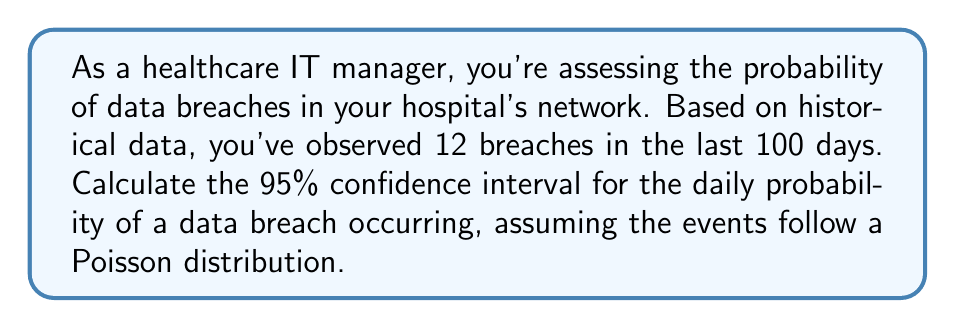Show me your answer to this math problem. Let's approach this step-by-step:

1) First, we need to calculate the point estimate for the daily probability of a data breach:
   $\hat{p} = \frac{\text{Number of breaches}}{\text{Number of days}} = \frac{12}{100} = 0.12$

2) For a Poisson distribution, the variance is equal to the mean. In this case, the mean is 12 breaches in 100 days.

3) The standard error (SE) for the Poisson distribution is given by:
   $SE = \sqrt{\frac{\lambda}{n}} = \sqrt{\frac{12}{100}} = 0.3464$

4) For a 95% confidence interval, we use a z-score of 1.96 (rounded to two decimal places).

5) The confidence interval is calculated as:
   $CI = \hat{p} \pm z \cdot SE$

6) Substituting our values:
   $CI = 0.12 \pm 1.96 \cdot 0.3464$

7) Calculating:
   $CI = 0.12 \pm 0.0679$

8) This gives us the interval:
   $(0.12 - 0.0679, 0.12 + 0.0679) = (0.0521, 0.1879)$

Therefore, we can say with 95% confidence that the daily probability of a data breach is between 0.0521 and 0.1879, or approximately 5.21% to 18.79%.
Answer: $(0.0521, 0.1879)$ 